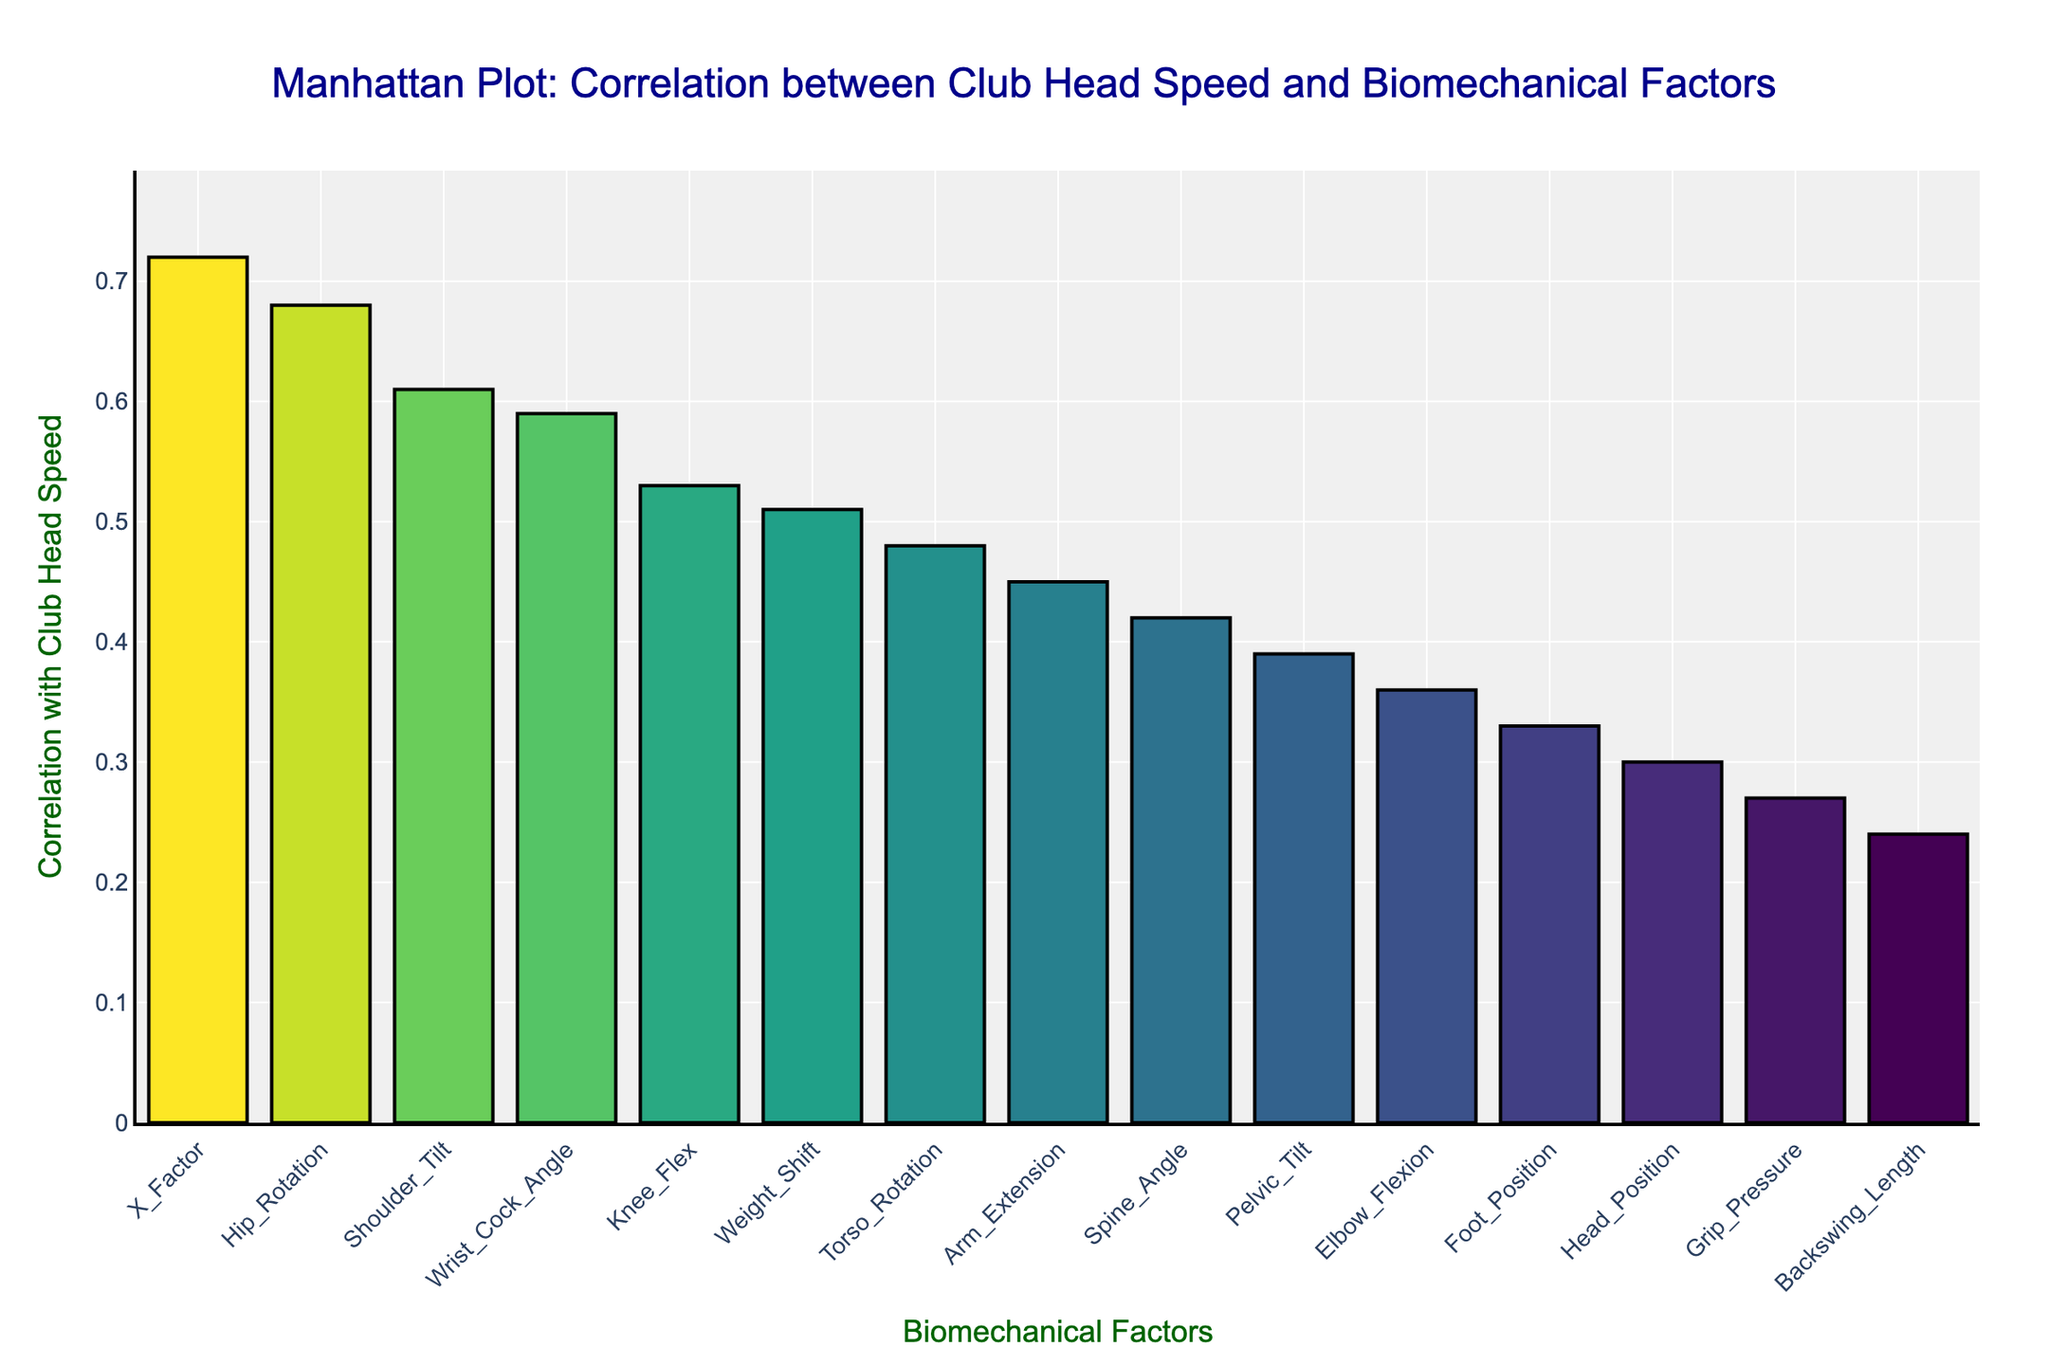What is the title of the plot? The title can be found at the top of the figure.
Answer: Manhattan Plot: Correlation between Club Head Speed and Biomechanical Factors Which biomechanical factor has the highest correlation with club head speed? The highest bar represents the factor with the highest correlation.
Answer: X_Factor How many biomechanical factors have a correlation greater than 0.5? Count the bars that are above the 0.5 correlation line on the y-axis.
Answer: 5 Which biomechanical factor has the lowest correlation with club head speed? The shortest bar represents the factor with the lowest correlation.
Answer: Backswing_Length What is the average correlation of the top three biomechanical factors? First, identify the top three factors: X_Factor (0.72), Hip_Rotation (0.68), and Shoulder_Tilt (0.61). Calculate the average of these values: (0.72 + 0.68 + 0.61)/3.
Answer: 0.67 What is the correlation difference between Shoulder_Tilt and Arm_Extension? Identify the correlation values: Shoulder_Tilt (0.61) and Arm_Extension (0.45). Subtract the smaller value from the larger value: 0.61 - 0.45.
Answer: 0.16 Which has a higher correlation with club head speed, Spine_Angle or Pelvic_Tilt? Compare the correlation values of Spine_Angle (0.42) and Pelvic_Tilt (0.39).
Answer: Spine_Angle What is the median correlation value of all biomechanical factors? List the correlation values in ascending order and find the middle value. The values are: 0.24, 0.27, 0.30, 0.33, 0.36, 0.39, 0.42, 0.45, 0.48, 0.51, 0.53, 0.59, 0.61, 0.68, 0.72, with the median being the 8th value.
Answer: 0.45 What is the correlation range of the biomechanical factors? Subtract the smallest correlation value (0.24) from the largest correlation value (0.72).
Answer: 0.48 